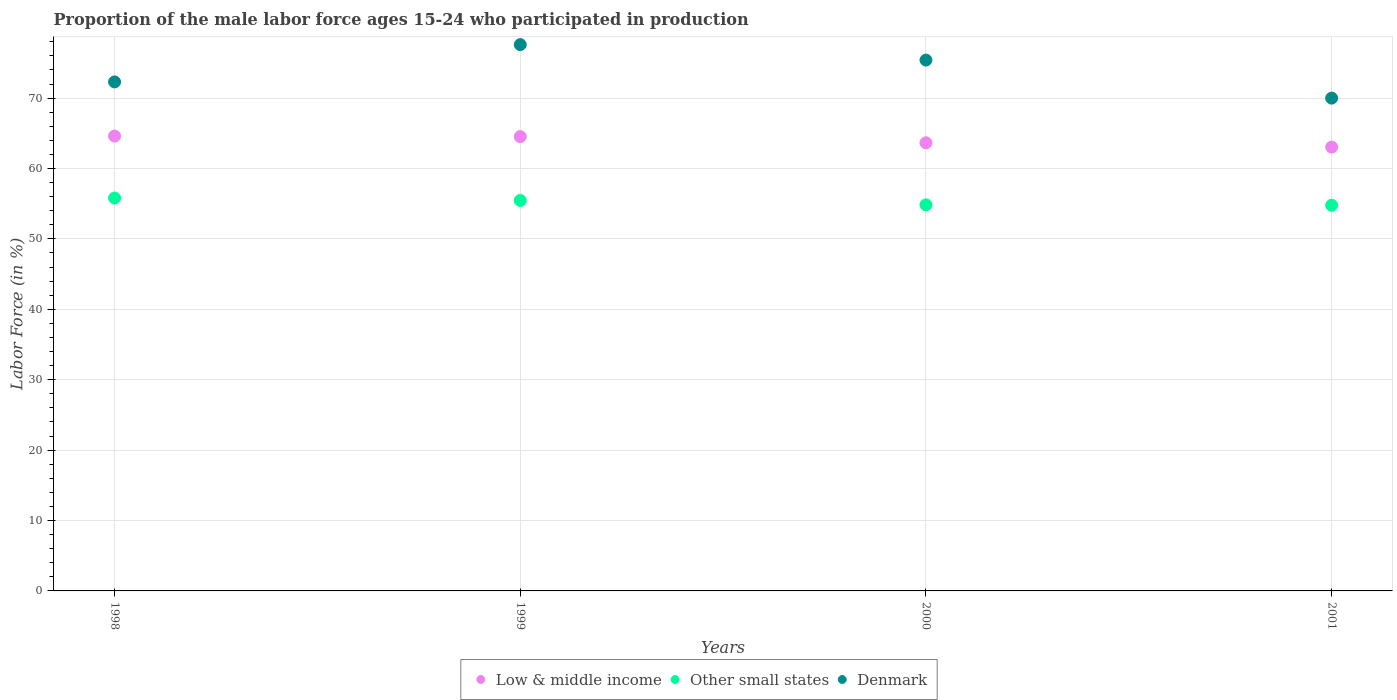How many different coloured dotlines are there?
Give a very brief answer. 3. Is the number of dotlines equal to the number of legend labels?
Make the answer very short. Yes. Across all years, what is the maximum proportion of the male labor force who participated in production in Denmark?
Offer a very short reply. 77.6. Across all years, what is the minimum proportion of the male labor force who participated in production in Low & middle income?
Your response must be concise. 63.04. In which year was the proportion of the male labor force who participated in production in Denmark maximum?
Your answer should be very brief. 1999. In which year was the proportion of the male labor force who participated in production in Denmark minimum?
Offer a very short reply. 2001. What is the total proportion of the male labor force who participated in production in Denmark in the graph?
Make the answer very short. 295.3. What is the difference between the proportion of the male labor force who participated in production in Denmark in 1999 and that in 2001?
Ensure brevity in your answer.  7.6. What is the difference between the proportion of the male labor force who participated in production in Other small states in 1999 and the proportion of the male labor force who participated in production in Denmark in 2001?
Offer a terse response. -14.54. What is the average proportion of the male labor force who participated in production in Denmark per year?
Offer a very short reply. 73.83. In the year 2000, what is the difference between the proportion of the male labor force who participated in production in Other small states and proportion of the male labor force who participated in production in Low & middle income?
Provide a succinct answer. -8.81. What is the ratio of the proportion of the male labor force who participated in production in Low & middle income in 2000 to that in 2001?
Offer a very short reply. 1.01. Is the proportion of the male labor force who participated in production in Low & middle income in 1998 less than that in 2000?
Make the answer very short. No. Is the difference between the proportion of the male labor force who participated in production in Other small states in 1998 and 2000 greater than the difference between the proportion of the male labor force who participated in production in Low & middle income in 1998 and 2000?
Keep it short and to the point. Yes. What is the difference between the highest and the second highest proportion of the male labor force who participated in production in Low & middle income?
Your response must be concise. 0.07. What is the difference between the highest and the lowest proportion of the male labor force who participated in production in Denmark?
Offer a terse response. 7.6. In how many years, is the proportion of the male labor force who participated in production in Denmark greater than the average proportion of the male labor force who participated in production in Denmark taken over all years?
Give a very brief answer. 2. Is it the case that in every year, the sum of the proportion of the male labor force who participated in production in Low & middle income and proportion of the male labor force who participated in production in Other small states  is greater than the proportion of the male labor force who participated in production in Denmark?
Make the answer very short. Yes. Is the proportion of the male labor force who participated in production in Other small states strictly greater than the proportion of the male labor force who participated in production in Denmark over the years?
Provide a short and direct response. No. Is the proportion of the male labor force who participated in production in Other small states strictly less than the proportion of the male labor force who participated in production in Low & middle income over the years?
Your response must be concise. Yes. How many years are there in the graph?
Keep it short and to the point. 4. What is the difference between two consecutive major ticks on the Y-axis?
Offer a terse response. 10. Does the graph contain grids?
Your response must be concise. Yes. How many legend labels are there?
Offer a very short reply. 3. How are the legend labels stacked?
Make the answer very short. Horizontal. What is the title of the graph?
Make the answer very short. Proportion of the male labor force ages 15-24 who participated in production. Does "Palau" appear as one of the legend labels in the graph?
Your response must be concise. No. What is the label or title of the X-axis?
Your answer should be very brief. Years. What is the Labor Force (in %) of Low & middle income in 1998?
Your answer should be compact. 64.61. What is the Labor Force (in %) of Other small states in 1998?
Ensure brevity in your answer.  55.81. What is the Labor Force (in %) in Denmark in 1998?
Your response must be concise. 72.3. What is the Labor Force (in %) in Low & middle income in 1999?
Offer a very short reply. 64.53. What is the Labor Force (in %) in Other small states in 1999?
Provide a succinct answer. 55.46. What is the Labor Force (in %) of Denmark in 1999?
Your answer should be very brief. 77.6. What is the Labor Force (in %) of Low & middle income in 2000?
Offer a terse response. 63.66. What is the Labor Force (in %) in Other small states in 2000?
Offer a terse response. 54.84. What is the Labor Force (in %) of Denmark in 2000?
Your answer should be very brief. 75.4. What is the Labor Force (in %) of Low & middle income in 2001?
Make the answer very short. 63.04. What is the Labor Force (in %) in Other small states in 2001?
Make the answer very short. 54.78. Across all years, what is the maximum Labor Force (in %) in Low & middle income?
Offer a very short reply. 64.61. Across all years, what is the maximum Labor Force (in %) in Other small states?
Your answer should be very brief. 55.81. Across all years, what is the maximum Labor Force (in %) in Denmark?
Make the answer very short. 77.6. Across all years, what is the minimum Labor Force (in %) in Low & middle income?
Offer a very short reply. 63.04. Across all years, what is the minimum Labor Force (in %) of Other small states?
Your answer should be compact. 54.78. What is the total Labor Force (in %) of Low & middle income in the graph?
Provide a short and direct response. 255.84. What is the total Labor Force (in %) in Other small states in the graph?
Make the answer very short. 220.9. What is the total Labor Force (in %) in Denmark in the graph?
Offer a very short reply. 295.3. What is the difference between the Labor Force (in %) of Low & middle income in 1998 and that in 1999?
Provide a short and direct response. 0.07. What is the difference between the Labor Force (in %) in Other small states in 1998 and that in 1999?
Your answer should be compact. 0.35. What is the difference between the Labor Force (in %) in Low & middle income in 1998 and that in 2000?
Keep it short and to the point. 0.95. What is the difference between the Labor Force (in %) in Other small states in 1998 and that in 2000?
Keep it short and to the point. 0.97. What is the difference between the Labor Force (in %) in Low & middle income in 1998 and that in 2001?
Keep it short and to the point. 1.56. What is the difference between the Labor Force (in %) of Other small states in 1998 and that in 2001?
Make the answer very short. 1.03. What is the difference between the Labor Force (in %) in Denmark in 1998 and that in 2001?
Ensure brevity in your answer.  2.3. What is the difference between the Labor Force (in %) of Low & middle income in 1999 and that in 2000?
Offer a very short reply. 0.87. What is the difference between the Labor Force (in %) in Other small states in 1999 and that in 2000?
Your answer should be compact. 0.62. What is the difference between the Labor Force (in %) in Denmark in 1999 and that in 2000?
Your answer should be very brief. 2.2. What is the difference between the Labor Force (in %) in Low & middle income in 1999 and that in 2001?
Keep it short and to the point. 1.49. What is the difference between the Labor Force (in %) of Other small states in 1999 and that in 2001?
Your response must be concise. 0.68. What is the difference between the Labor Force (in %) of Denmark in 1999 and that in 2001?
Give a very brief answer. 7.6. What is the difference between the Labor Force (in %) of Low & middle income in 2000 and that in 2001?
Offer a very short reply. 0.61. What is the difference between the Labor Force (in %) in Other small states in 2000 and that in 2001?
Provide a succinct answer. 0.06. What is the difference between the Labor Force (in %) in Low & middle income in 1998 and the Labor Force (in %) in Other small states in 1999?
Provide a succinct answer. 9.14. What is the difference between the Labor Force (in %) of Low & middle income in 1998 and the Labor Force (in %) of Denmark in 1999?
Your answer should be very brief. -12.99. What is the difference between the Labor Force (in %) of Other small states in 1998 and the Labor Force (in %) of Denmark in 1999?
Offer a very short reply. -21.79. What is the difference between the Labor Force (in %) of Low & middle income in 1998 and the Labor Force (in %) of Other small states in 2000?
Give a very brief answer. 9.76. What is the difference between the Labor Force (in %) in Low & middle income in 1998 and the Labor Force (in %) in Denmark in 2000?
Your answer should be very brief. -10.79. What is the difference between the Labor Force (in %) in Other small states in 1998 and the Labor Force (in %) in Denmark in 2000?
Offer a terse response. -19.59. What is the difference between the Labor Force (in %) in Low & middle income in 1998 and the Labor Force (in %) in Other small states in 2001?
Provide a succinct answer. 9.82. What is the difference between the Labor Force (in %) in Low & middle income in 1998 and the Labor Force (in %) in Denmark in 2001?
Offer a terse response. -5.39. What is the difference between the Labor Force (in %) of Other small states in 1998 and the Labor Force (in %) of Denmark in 2001?
Your response must be concise. -14.19. What is the difference between the Labor Force (in %) of Low & middle income in 1999 and the Labor Force (in %) of Other small states in 2000?
Make the answer very short. 9.69. What is the difference between the Labor Force (in %) of Low & middle income in 1999 and the Labor Force (in %) of Denmark in 2000?
Give a very brief answer. -10.87. What is the difference between the Labor Force (in %) of Other small states in 1999 and the Labor Force (in %) of Denmark in 2000?
Your response must be concise. -19.94. What is the difference between the Labor Force (in %) in Low & middle income in 1999 and the Labor Force (in %) in Other small states in 2001?
Keep it short and to the point. 9.75. What is the difference between the Labor Force (in %) of Low & middle income in 1999 and the Labor Force (in %) of Denmark in 2001?
Your answer should be compact. -5.47. What is the difference between the Labor Force (in %) in Other small states in 1999 and the Labor Force (in %) in Denmark in 2001?
Ensure brevity in your answer.  -14.54. What is the difference between the Labor Force (in %) in Low & middle income in 2000 and the Labor Force (in %) in Other small states in 2001?
Ensure brevity in your answer.  8.88. What is the difference between the Labor Force (in %) in Low & middle income in 2000 and the Labor Force (in %) in Denmark in 2001?
Ensure brevity in your answer.  -6.34. What is the difference between the Labor Force (in %) of Other small states in 2000 and the Labor Force (in %) of Denmark in 2001?
Give a very brief answer. -15.16. What is the average Labor Force (in %) in Low & middle income per year?
Your answer should be compact. 63.96. What is the average Labor Force (in %) of Other small states per year?
Your answer should be compact. 55.22. What is the average Labor Force (in %) in Denmark per year?
Provide a succinct answer. 73.83. In the year 1998, what is the difference between the Labor Force (in %) of Low & middle income and Labor Force (in %) of Other small states?
Offer a terse response. 8.8. In the year 1998, what is the difference between the Labor Force (in %) of Low & middle income and Labor Force (in %) of Denmark?
Your answer should be compact. -7.69. In the year 1998, what is the difference between the Labor Force (in %) in Other small states and Labor Force (in %) in Denmark?
Offer a very short reply. -16.49. In the year 1999, what is the difference between the Labor Force (in %) of Low & middle income and Labor Force (in %) of Other small states?
Offer a very short reply. 9.07. In the year 1999, what is the difference between the Labor Force (in %) of Low & middle income and Labor Force (in %) of Denmark?
Provide a succinct answer. -13.07. In the year 1999, what is the difference between the Labor Force (in %) of Other small states and Labor Force (in %) of Denmark?
Provide a succinct answer. -22.14. In the year 2000, what is the difference between the Labor Force (in %) in Low & middle income and Labor Force (in %) in Other small states?
Provide a succinct answer. 8.81. In the year 2000, what is the difference between the Labor Force (in %) in Low & middle income and Labor Force (in %) in Denmark?
Provide a short and direct response. -11.74. In the year 2000, what is the difference between the Labor Force (in %) of Other small states and Labor Force (in %) of Denmark?
Ensure brevity in your answer.  -20.56. In the year 2001, what is the difference between the Labor Force (in %) of Low & middle income and Labor Force (in %) of Other small states?
Offer a terse response. 8.26. In the year 2001, what is the difference between the Labor Force (in %) of Low & middle income and Labor Force (in %) of Denmark?
Ensure brevity in your answer.  -6.96. In the year 2001, what is the difference between the Labor Force (in %) of Other small states and Labor Force (in %) of Denmark?
Keep it short and to the point. -15.22. What is the ratio of the Labor Force (in %) in Other small states in 1998 to that in 1999?
Offer a terse response. 1.01. What is the ratio of the Labor Force (in %) in Denmark in 1998 to that in 1999?
Provide a succinct answer. 0.93. What is the ratio of the Labor Force (in %) in Low & middle income in 1998 to that in 2000?
Provide a short and direct response. 1.01. What is the ratio of the Labor Force (in %) of Other small states in 1998 to that in 2000?
Make the answer very short. 1.02. What is the ratio of the Labor Force (in %) of Denmark in 1998 to that in 2000?
Ensure brevity in your answer.  0.96. What is the ratio of the Labor Force (in %) of Low & middle income in 1998 to that in 2001?
Offer a very short reply. 1.02. What is the ratio of the Labor Force (in %) in Other small states in 1998 to that in 2001?
Provide a succinct answer. 1.02. What is the ratio of the Labor Force (in %) of Denmark in 1998 to that in 2001?
Offer a very short reply. 1.03. What is the ratio of the Labor Force (in %) of Low & middle income in 1999 to that in 2000?
Your answer should be compact. 1.01. What is the ratio of the Labor Force (in %) of Other small states in 1999 to that in 2000?
Make the answer very short. 1.01. What is the ratio of the Labor Force (in %) of Denmark in 1999 to that in 2000?
Offer a terse response. 1.03. What is the ratio of the Labor Force (in %) of Low & middle income in 1999 to that in 2001?
Provide a short and direct response. 1.02. What is the ratio of the Labor Force (in %) in Other small states in 1999 to that in 2001?
Provide a short and direct response. 1.01. What is the ratio of the Labor Force (in %) in Denmark in 1999 to that in 2001?
Offer a very short reply. 1.11. What is the ratio of the Labor Force (in %) of Low & middle income in 2000 to that in 2001?
Provide a succinct answer. 1.01. What is the ratio of the Labor Force (in %) of Denmark in 2000 to that in 2001?
Make the answer very short. 1.08. What is the difference between the highest and the second highest Labor Force (in %) of Low & middle income?
Offer a very short reply. 0.07. What is the difference between the highest and the second highest Labor Force (in %) of Other small states?
Ensure brevity in your answer.  0.35. What is the difference between the highest and the lowest Labor Force (in %) of Low & middle income?
Provide a short and direct response. 1.56. What is the difference between the highest and the lowest Labor Force (in %) of Other small states?
Your answer should be compact. 1.03. What is the difference between the highest and the lowest Labor Force (in %) of Denmark?
Make the answer very short. 7.6. 